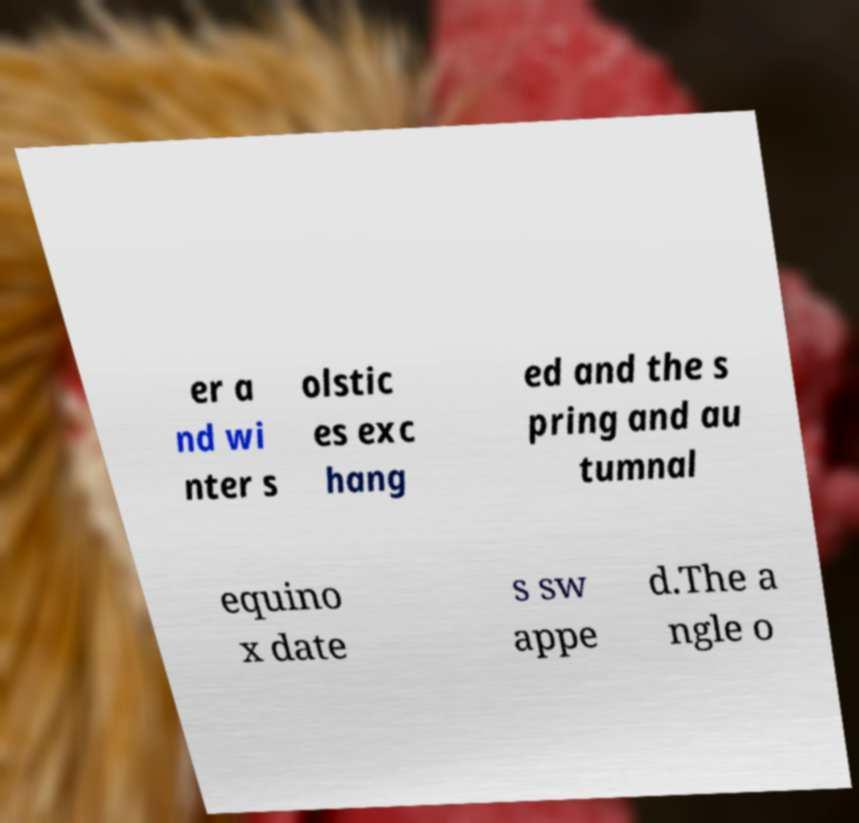What messages or text are displayed in this image? I need them in a readable, typed format. er a nd wi nter s olstic es exc hang ed and the s pring and au tumnal equino x date s sw appe d.The a ngle o 